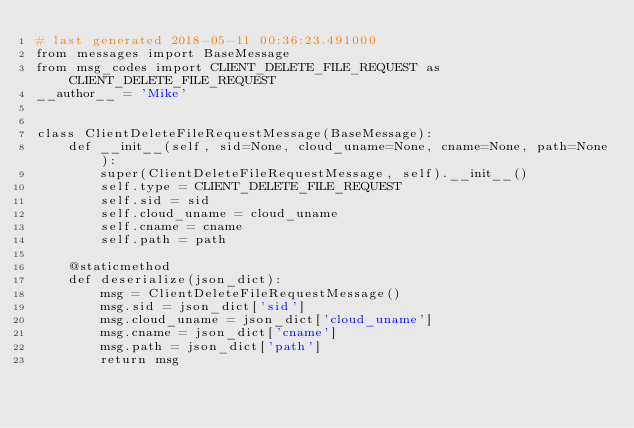Convert code to text. <code><loc_0><loc_0><loc_500><loc_500><_Python_># last generated 2018-05-11 00:36:23.491000
from messages import BaseMessage
from msg_codes import CLIENT_DELETE_FILE_REQUEST as CLIENT_DELETE_FILE_REQUEST
__author__ = 'Mike'


class ClientDeleteFileRequestMessage(BaseMessage):
    def __init__(self, sid=None, cloud_uname=None, cname=None, path=None):
        super(ClientDeleteFileRequestMessage, self).__init__()
        self.type = CLIENT_DELETE_FILE_REQUEST
        self.sid = sid
        self.cloud_uname = cloud_uname
        self.cname = cname
        self.path = path

    @staticmethod
    def deserialize(json_dict):
        msg = ClientDeleteFileRequestMessage()
        msg.sid = json_dict['sid']
        msg.cloud_uname = json_dict['cloud_uname']
        msg.cname = json_dict['cname']
        msg.path = json_dict['path']
        return msg

</code> 